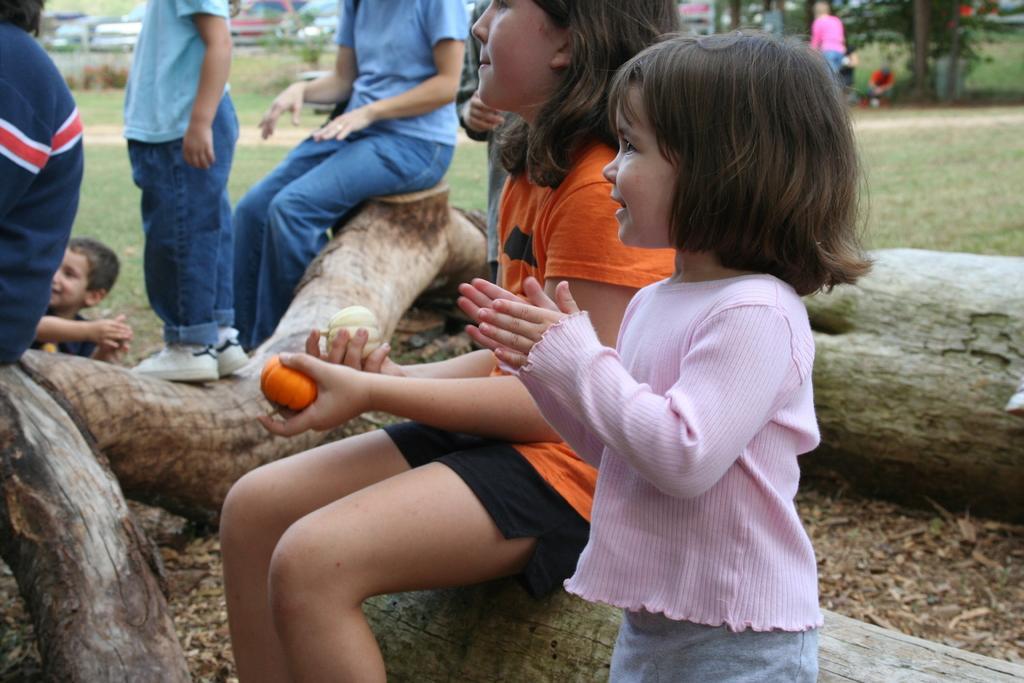Please provide a concise description of this image. As we can see in the image there are tree stems, few people here and there and grass. In the background there are cars. 